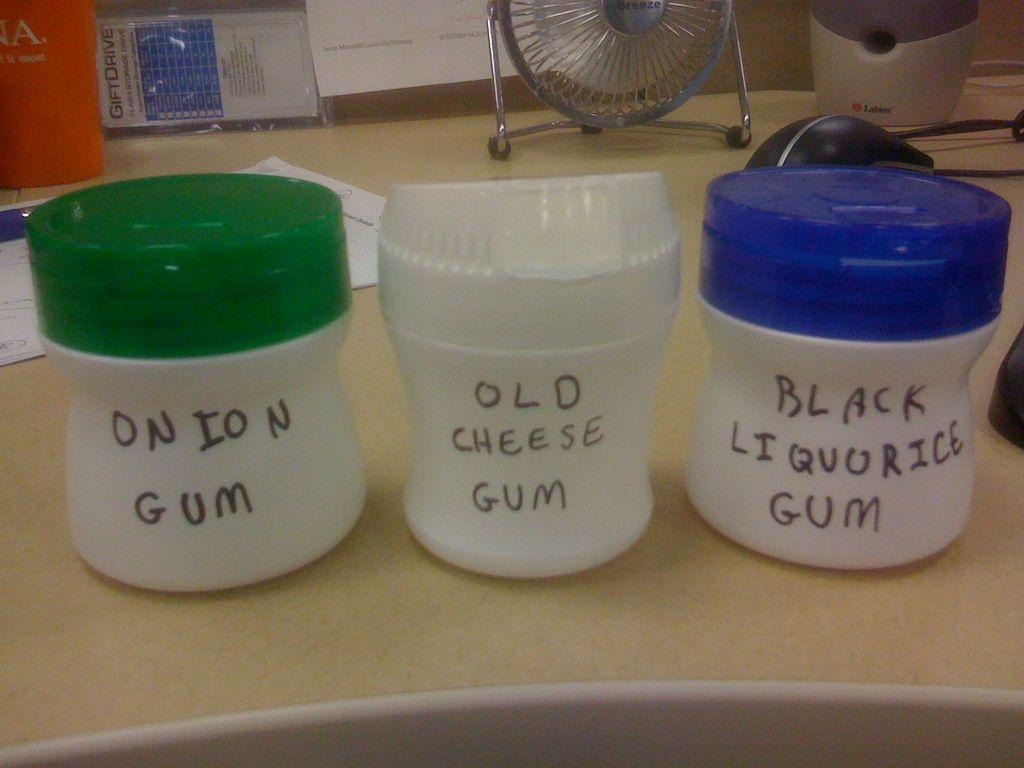Provide a one-sentence caption for the provided image. Three jars with the names onion gum, old cheese gum and black liquorice sit on a counter. 